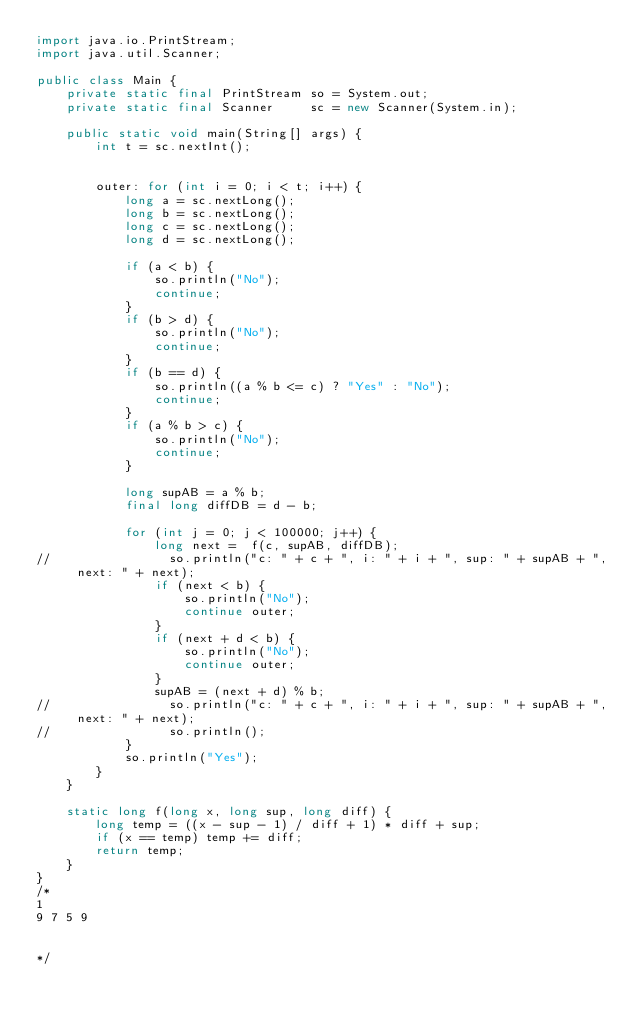Convert code to text. <code><loc_0><loc_0><loc_500><loc_500><_Java_>import java.io.PrintStream;
import java.util.Scanner;

public class Main {
    private static final PrintStream so = System.out;
    private static final Scanner     sc = new Scanner(System.in);

    public static void main(String[] args) {
        int t = sc.nextInt();
        

        outer: for (int i = 0; i < t; i++) {
            long a = sc.nextLong();
            long b = sc.nextLong();
            long c = sc.nextLong();
            long d = sc.nextLong();
            
            if (a < b) {
                so.println("No");
                continue;
            }
            if (b > d) {
                so.println("No");
                continue;
            }
            if (b == d) {
                so.println((a % b <= c) ? "Yes" : "No");
                continue;
            }
            if (a % b > c) {
                so.println("No");
                continue;
            }
            
            long supAB = a % b;
            final long diffDB = d - b;
            
            for (int j = 0; j < 100000; j++) {
                long next =  f(c, supAB, diffDB);
//                so.println("c: " + c + ", i: " + i + ", sup: " + supAB + ", next: " + next);
                if (next < b) {
                    so.println("No");
                    continue outer;
                }
                if (next + d < b) {
                    so.println("No");
                    continue outer;
                }
                supAB = (next + d) % b;
//                so.println("c: " + c + ", i: " + i + ", sup: " + supAB + ", next: " + next);
//                so.println();
            }
            so.println("Yes");
        }
    }
    
    static long f(long x, long sup, long diff) {
        long temp = ((x - sup - 1) / diff + 1) * diff + sup;
        if (x == temp) temp += diff;
        return temp;
    }
}
/*
1
9 7 5 9


*/</code> 